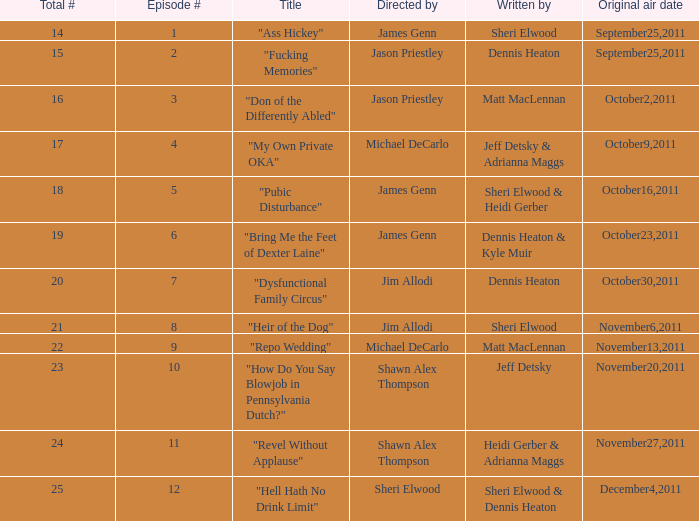How many distinct episode numbers does the episode penned by sheri elwood and helmed by jim allodi possess? 1.0. 